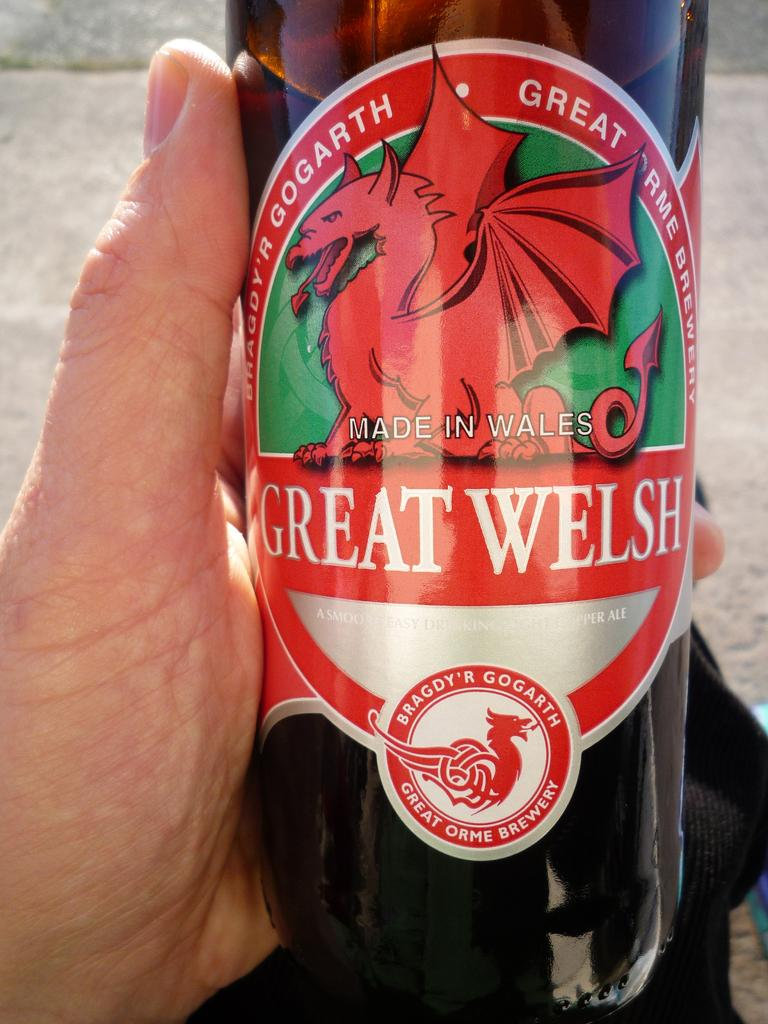What object can be seen in the image? There is a bottle in the image. Who or what is interacting with the bottle? Someone is holding the bottle with their hand. What type of camera is being used to take a picture of the box in the image? There is no box or camera present in the image; it only features a bottle and someone holding it. 